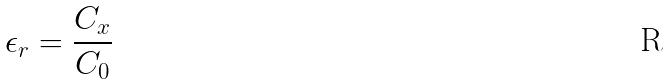<formula> <loc_0><loc_0><loc_500><loc_500>\epsilon _ { r } = \frac { C _ { x } } { C _ { 0 } }</formula> 